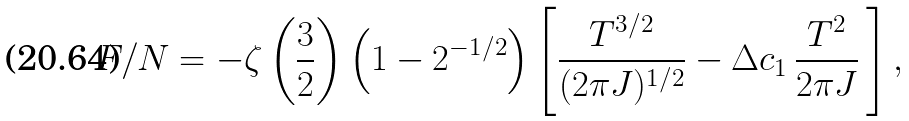<formula> <loc_0><loc_0><loc_500><loc_500>F / N = - \zeta \left ( { \frac { 3 } { 2 } } \right ) \left ( 1 - 2 ^ { - 1 / 2 } \right ) \left [ \frac { T ^ { 3 / 2 } } { ( 2 \pi J ) ^ { 1 / 2 } } - \Delta c _ { 1 } \, \frac { T ^ { 2 } } { 2 \pi J } \, \right ] ,</formula> 